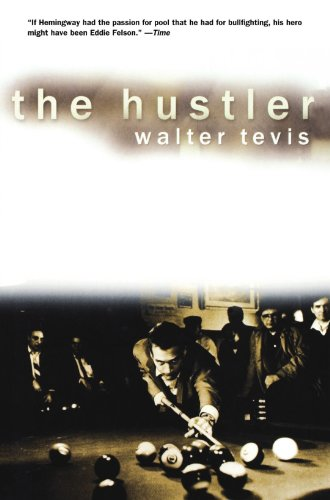Could you tell me more about the main character of this book? The main character of 'The Hustler' is 'Fast Eddie' Felson, a highly skilled pool hustler with big dreams and a desire to prove himself as the best pool player by challenging legendary players. 